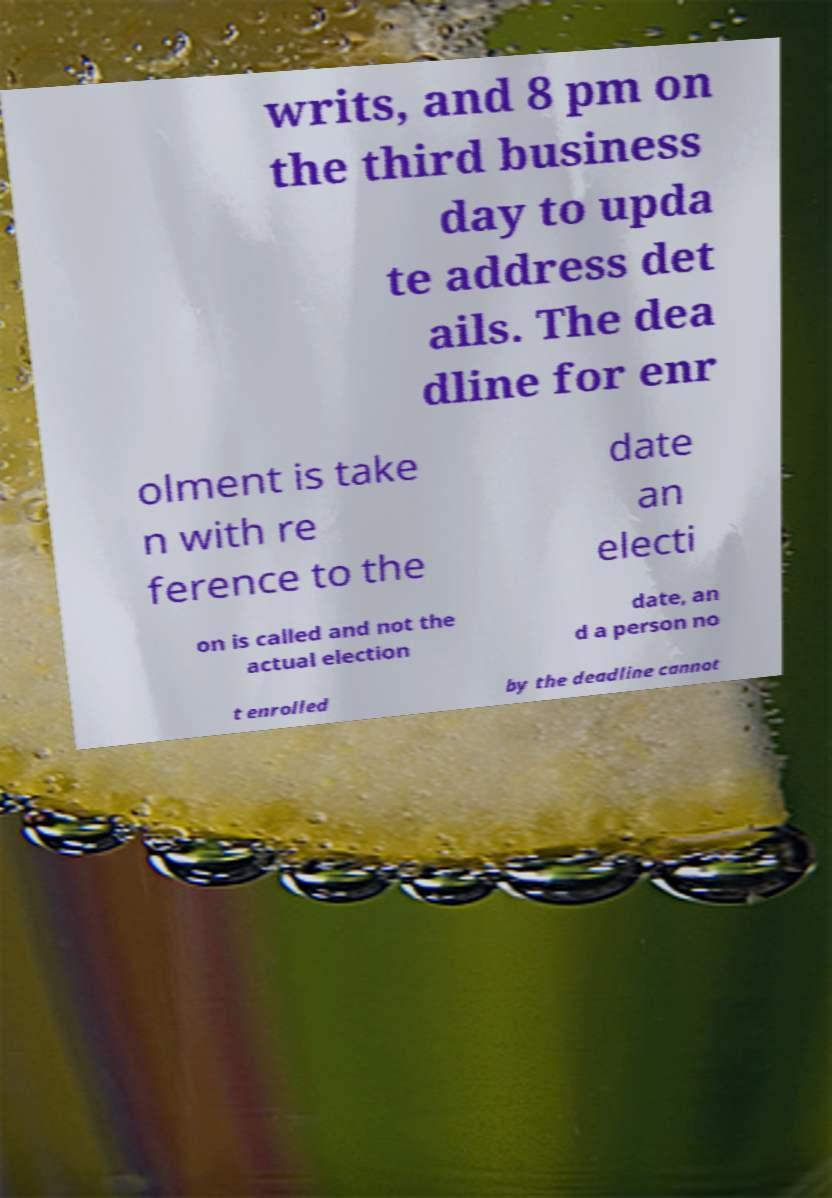There's text embedded in this image that I need extracted. Can you transcribe it verbatim? writs, and 8 pm on the third business day to upda te address det ails. The dea dline for enr olment is take n with re ference to the date an electi on is called and not the actual election date, an d a person no t enrolled by the deadline cannot 